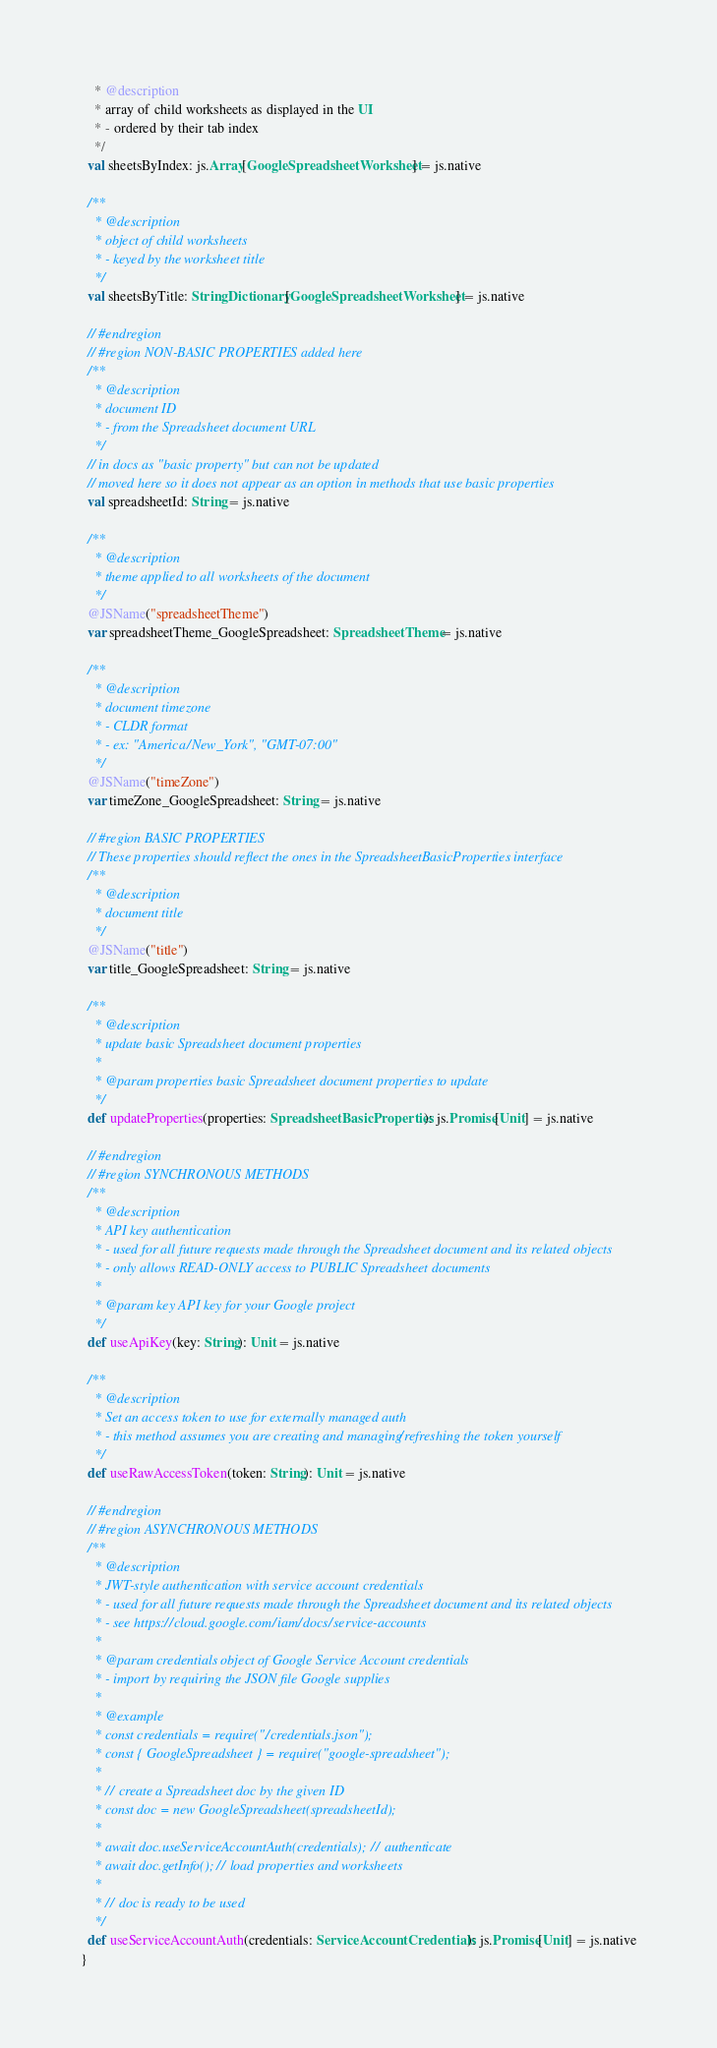Convert code to text. <code><loc_0><loc_0><loc_500><loc_500><_Scala_>    * @description
    * array of child worksheets as displayed in the UI
    * - ordered by their tab index
    */
  val sheetsByIndex: js.Array[GoogleSpreadsheetWorksheet] = js.native
  
  /**
    * @description
    * object of child worksheets
    * - keyed by the worksheet title
    */
  val sheetsByTitle: StringDictionary[GoogleSpreadsheetWorksheet] = js.native
  
  // #endregion
  // #region NON-BASIC PROPERTIES added here
  /**
    * @description
    * document ID
    * - from the Spreadsheet document URL
    */
  // in docs as "basic property" but can not be updated
  // moved here so it does not appear as an option in methods that use basic properties
  val spreadsheetId: String = js.native
  
  /**
    * @description
    * theme applied to all worksheets of the document
    */
  @JSName("spreadsheetTheme")
  var spreadsheetTheme_GoogleSpreadsheet: SpreadsheetTheme = js.native
  
  /**
    * @description
    * document timezone
    * - CLDR format
    * - ex: "America/New_York", "GMT-07:00"
    */
  @JSName("timeZone")
  var timeZone_GoogleSpreadsheet: String = js.native
  
  // #region BASIC PROPERTIES
  // These properties should reflect the ones in the SpreadsheetBasicProperties interface
  /**
    * @description
    * document title
    */
  @JSName("title")
  var title_GoogleSpreadsheet: String = js.native
  
  /**
    * @description
    * update basic Spreadsheet document properties
    *
    * @param properties basic Spreadsheet document properties to update
    */
  def updateProperties(properties: SpreadsheetBasicProperties): js.Promise[Unit] = js.native
  
  // #endregion
  // #region SYNCHRONOUS METHODS
  /**
    * @description
    * API key authentication
    * - used for all future requests made through the Spreadsheet document and its related objects
    * - only allows READ-ONLY access to PUBLIC Spreadsheet documents
    *
    * @param key API key for your Google project
    */
  def useApiKey(key: String): Unit = js.native
  
  /**
    * @description
    * Set an access token to use for externally managed auth
    * - this method assumes you are creating and managing/refreshing the token yourself
    */
  def useRawAccessToken(token: String): Unit = js.native
  
  // #endregion
  // #region ASYNCHRONOUS METHODS
  /**
    * @description
    * JWT-style authentication with service account credentials
    * - used for all future requests made through the Spreadsheet document and its related objects
    * - see https://cloud.google.com/iam/docs/service-accounts
    *
    * @param credentials object of Google Service Account credentials
    * - import by requiring the JSON file Google supplies
    *
    * @example
    * const credentials = require("./credentials.json");
    * const { GoogleSpreadsheet } = require("google-spreadsheet");
    *
    * // create a Spreadsheet doc by the given ID
    * const doc = new GoogleSpreadsheet(spreadsheetId);
    *
    * await doc.useServiceAccountAuth(credentials); // authenticate
    * await doc.getInfo(); // load properties and worksheets
    *
    * // doc is ready to be used
    */
  def useServiceAccountAuth(credentials: ServiceAccountCredentials): js.Promise[Unit] = js.native
}
</code> 